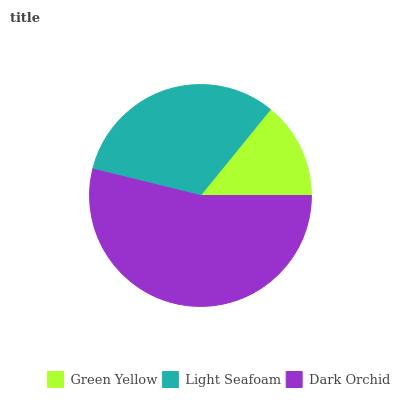Is Green Yellow the minimum?
Answer yes or no. Yes. Is Dark Orchid the maximum?
Answer yes or no. Yes. Is Light Seafoam the minimum?
Answer yes or no. No. Is Light Seafoam the maximum?
Answer yes or no. No. Is Light Seafoam greater than Green Yellow?
Answer yes or no. Yes. Is Green Yellow less than Light Seafoam?
Answer yes or no. Yes. Is Green Yellow greater than Light Seafoam?
Answer yes or no. No. Is Light Seafoam less than Green Yellow?
Answer yes or no. No. Is Light Seafoam the high median?
Answer yes or no. Yes. Is Light Seafoam the low median?
Answer yes or no. Yes. Is Dark Orchid the high median?
Answer yes or no. No. Is Dark Orchid the low median?
Answer yes or no. No. 